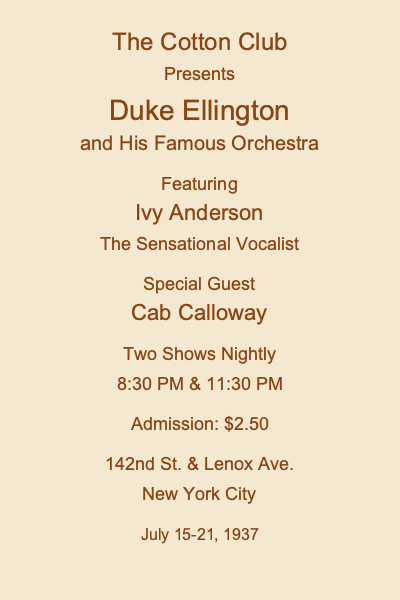Based on the vintage jazz club poster, what can we infer about the typical admission price for a high-profile jazz performance in Harlem during the late 1930s, and how might this relate to the economic conditions of the time? To answer this question, we need to analyze the information provided on the poster and consider the historical context of the late 1930s:

1. Admission price: The poster shows an admission price of $2.50.

2. Venue: The Cotton Club, located at 142nd St. & Lenox Ave. in New York City, was a famous jazz club in Harlem.

3. Performers: The poster features Duke Ellington and His Famous Orchestra, Ivy Anderson, and Cab Calloway, all well-known and popular jazz artists of the time.

4. Date: The performance is scheduled for July 15-21, 1937, placing it in the late 1930s.

5. Historical context: The late 1930s was a period of economic recovery following the Great Depression, but many people were still struggling financially.

6. Purchasing power: To understand the significance of the $2.50 admission price, we need to consider its equivalent value in today's currency. Using rough inflation calculators, $2.50 in 1937 would be equivalent to approximately $45-$50 in 2023.

7. Accessibility: Given the economic conditions of the time, this admission price would have been relatively expensive for the average person, suggesting that attending such performances was likely a luxury for many.

8. Target audience: The Cotton Club was known for catering to white audiences despite featuring Black performers, which may have influenced its pricing strategy.

9. Multiple shows: The poster advertises two shows nightly, indicating high demand and potentially justifying the higher admission price.

Based on this analysis, we can infer that the $2.50 admission price for a high-profile jazz performance in Harlem during the late 1930s was relatively expensive, reflecting both the caliber of the performers and the exclusive nature of venues like the Cotton Club. This price point suggests that such performances were not easily accessible to the average person during a time of economic recovery, highlighting the complex intersection of race, class, and entertainment in the jazz age.
Answer: The $2.50 admission price (equivalent to $45-$50 today) indicates that high-profile jazz performances were relatively expensive luxury events, reflecting the era's economic conditions and social dynamics. 